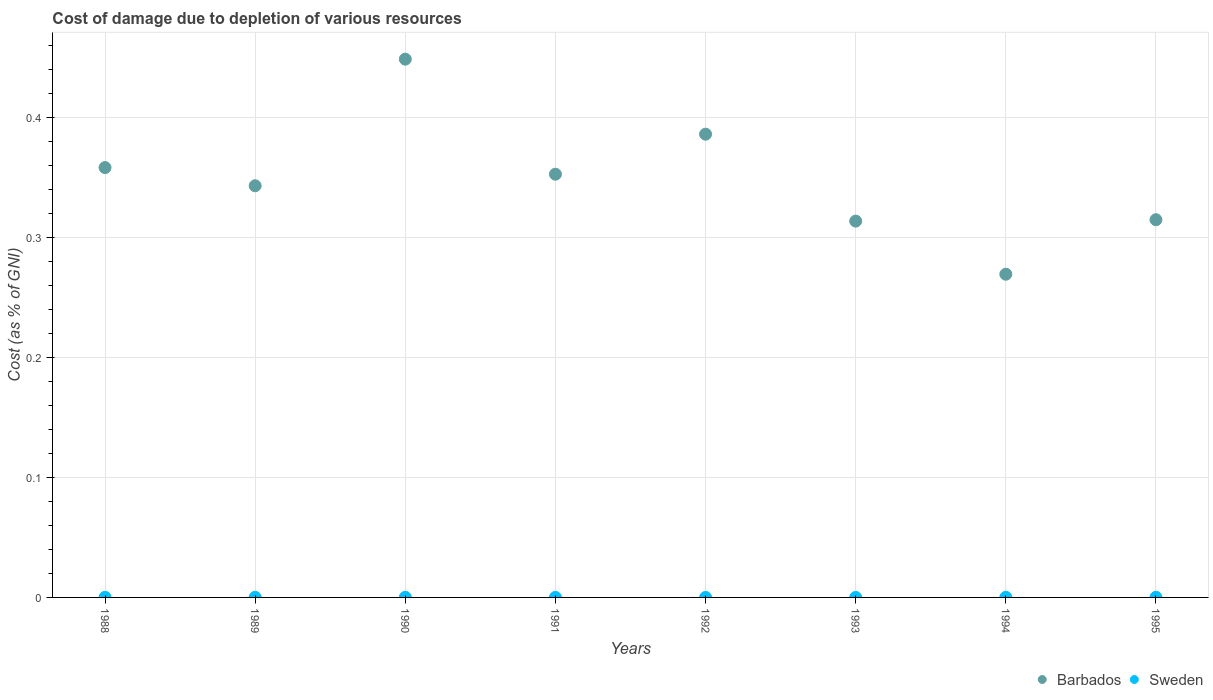How many different coloured dotlines are there?
Your response must be concise. 2. What is the cost of damage caused due to the depletion of various resources in Sweden in 1994?
Your answer should be compact. 0. Across all years, what is the maximum cost of damage caused due to the depletion of various resources in Sweden?
Your answer should be compact. 0. Across all years, what is the minimum cost of damage caused due to the depletion of various resources in Sweden?
Provide a short and direct response. 1.59427180676693e-5. What is the total cost of damage caused due to the depletion of various resources in Barbados in the graph?
Ensure brevity in your answer.  2.79. What is the difference between the cost of damage caused due to the depletion of various resources in Barbados in 1991 and that in 1995?
Provide a short and direct response. 0.04. What is the difference between the cost of damage caused due to the depletion of various resources in Sweden in 1989 and the cost of damage caused due to the depletion of various resources in Barbados in 1995?
Provide a succinct answer. -0.31. What is the average cost of damage caused due to the depletion of various resources in Sweden per year?
Your answer should be compact. 6.984566368503235e-5. In the year 1989, what is the difference between the cost of damage caused due to the depletion of various resources in Sweden and cost of damage caused due to the depletion of various resources in Barbados?
Your response must be concise. -0.34. In how many years, is the cost of damage caused due to the depletion of various resources in Sweden greater than 0.04 %?
Provide a succinct answer. 0. What is the ratio of the cost of damage caused due to the depletion of various resources in Barbados in 1993 to that in 1995?
Keep it short and to the point. 1. Is the cost of damage caused due to the depletion of various resources in Sweden in 1989 less than that in 1995?
Your answer should be very brief. Yes. Is the difference between the cost of damage caused due to the depletion of various resources in Sweden in 1989 and 1991 greater than the difference between the cost of damage caused due to the depletion of various resources in Barbados in 1989 and 1991?
Your answer should be very brief. Yes. What is the difference between the highest and the second highest cost of damage caused due to the depletion of various resources in Barbados?
Make the answer very short. 0.06. What is the difference between the highest and the lowest cost of damage caused due to the depletion of various resources in Sweden?
Provide a short and direct response. 9.43460556971317e-5. Is the sum of the cost of damage caused due to the depletion of various resources in Sweden in 1988 and 1992 greater than the maximum cost of damage caused due to the depletion of various resources in Barbados across all years?
Provide a succinct answer. No. Does the cost of damage caused due to the depletion of various resources in Sweden monotonically increase over the years?
Give a very brief answer. No. Is the cost of damage caused due to the depletion of various resources in Barbados strictly greater than the cost of damage caused due to the depletion of various resources in Sweden over the years?
Your answer should be compact. Yes. How many years are there in the graph?
Make the answer very short. 8. Are the values on the major ticks of Y-axis written in scientific E-notation?
Give a very brief answer. No. Does the graph contain grids?
Keep it short and to the point. Yes. Where does the legend appear in the graph?
Your answer should be compact. Bottom right. How are the legend labels stacked?
Give a very brief answer. Horizontal. What is the title of the graph?
Your answer should be very brief. Cost of damage due to depletion of various resources. Does "Hong Kong" appear as one of the legend labels in the graph?
Your response must be concise. No. What is the label or title of the Y-axis?
Give a very brief answer. Cost (as % of GNI). What is the Cost (as % of GNI) of Barbados in 1988?
Give a very brief answer. 0.36. What is the Cost (as % of GNI) in Sweden in 1988?
Offer a very short reply. 6.97562237093655e-5. What is the Cost (as % of GNI) of Barbados in 1989?
Provide a succinct answer. 0.34. What is the Cost (as % of GNI) in Sweden in 1989?
Make the answer very short. 8.442372501403629e-5. What is the Cost (as % of GNI) in Barbados in 1990?
Your answer should be compact. 0.45. What is the Cost (as % of GNI) in Sweden in 1990?
Your answer should be very brief. 9.81903606188115e-5. What is the Cost (as % of GNI) of Barbados in 1991?
Ensure brevity in your answer.  0.35. What is the Cost (as % of GNI) in Sweden in 1991?
Give a very brief answer. 5.16035580745399e-5. What is the Cost (as % of GNI) of Barbados in 1992?
Your answer should be compact. 0.39. What is the Cost (as % of GNI) of Sweden in 1992?
Your response must be concise. 2.46812414981984e-5. What is the Cost (as % of GNI) in Barbados in 1993?
Your response must be concise. 0.31. What is the Cost (as % of GNI) of Sweden in 1993?
Provide a succinct answer. 1.59427180676693e-5. What is the Cost (as % of GNI) of Barbados in 1994?
Offer a very short reply. 0.27. What is the Cost (as % of GNI) in Sweden in 1994?
Keep it short and to the point. 0. What is the Cost (as % of GNI) in Barbados in 1995?
Give a very brief answer. 0.32. What is the Cost (as % of GNI) in Sweden in 1995?
Keep it short and to the point. 0. Across all years, what is the maximum Cost (as % of GNI) of Barbados?
Your answer should be very brief. 0.45. Across all years, what is the maximum Cost (as % of GNI) of Sweden?
Ensure brevity in your answer.  0. Across all years, what is the minimum Cost (as % of GNI) of Barbados?
Keep it short and to the point. 0.27. Across all years, what is the minimum Cost (as % of GNI) in Sweden?
Provide a succinct answer. 1.59427180676693e-5. What is the total Cost (as % of GNI) of Barbados in the graph?
Your answer should be very brief. 2.79. What is the total Cost (as % of GNI) in Sweden in the graph?
Provide a short and direct response. 0. What is the difference between the Cost (as % of GNI) of Barbados in 1988 and that in 1989?
Offer a very short reply. 0.02. What is the difference between the Cost (as % of GNI) in Barbados in 1988 and that in 1990?
Ensure brevity in your answer.  -0.09. What is the difference between the Cost (as % of GNI) in Barbados in 1988 and that in 1991?
Offer a terse response. 0.01. What is the difference between the Cost (as % of GNI) of Barbados in 1988 and that in 1992?
Your answer should be compact. -0.03. What is the difference between the Cost (as % of GNI) in Barbados in 1988 and that in 1993?
Offer a very short reply. 0.04. What is the difference between the Cost (as % of GNI) in Barbados in 1988 and that in 1994?
Keep it short and to the point. 0.09. What is the difference between the Cost (as % of GNI) in Barbados in 1988 and that in 1995?
Your answer should be very brief. 0.04. What is the difference between the Cost (as % of GNI) of Sweden in 1988 and that in 1995?
Your response must be concise. -0. What is the difference between the Cost (as % of GNI) in Barbados in 1989 and that in 1990?
Offer a terse response. -0.11. What is the difference between the Cost (as % of GNI) of Barbados in 1989 and that in 1991?
Give a very brief answer. -0.01. What is the difference between the Cost (as % of GNI) of Sweden in 1989 and that in 1991?
Give a very brief answer. 0. What is the difference between the Cost (as % of GNI) in Barbados in 1989 and that in 1992?
Your response must be concise. -0.04. What is the difference between the Cost (as % of GNI) in Barbados in 1989 and that in 1993?
Offer a very short reply. 0.03. What is the difference between the Cost (as % of GNI) in Sweden in 1989 and that in 1993?
Offer a terse response. 0. What is the difference between the Cost (as % of GNI) of Barbados in 1989 and that in 1994?
Ensure brevity in your answer.  0.07. What is the difference between the Cost (as % of GNI) in Barbados in 1989 and that in 1995?
Make the answer very short. 0.03. What is the difference between the Cost (as % of GNI) in Barbados in 1990 and that in 1991?
Make the answer very short. 0.1. What is the difference between the Cost (as % of GNI) of Barbados in 1990 and that in 1992?
Provide a short and direct response. 0.06. What is the difference between the Cost (as % of GNI) in Sweden in 1990 and that in 1992?
Provide a short and direct response. 0. What is the difference between the Cost (as % of GNI) of Barbados in 1990 and that in 1993?
Your answer should be very brief. 0.14. What is the difference between the Cost (as % of GNI) in Barbados in 1990 and that in 1994?
Keep it short and to the point. 0.18. What is the difference between the Cost (as % of GNI) in Barbados in 1990 and that in 1995?
Provide a succinct answer. 0.13. What is the difference between the Cost (as % of GNI) in Barbados in 1991 and that in 1992?
Your answer should be very brief. -0.03. What is the difference between the Cost (as % of GNI) in Sweden in 1991 and that in 1992?
Provide a succinct answer. 0. What is the difference between the Cost (as % of GNI) in Barbados in 1991 and that in 1993?
Keep it short and to the point. 0.04. What is the difference between the Cost (as % of GNI) in Sweden in 1991 and that in 1993?
Keep it short and to the point. 0. What is the difference between the Cost (as % of GNI) in Barbados in 1991 and that in 1994?
Your response must be concise. 0.08. What is the difference between the Cost (as % of GNI) of Sweden in 1991 and that in 1994?
Offer a terse response. -0. What is the difference between the Cost (as % of GNI) in Barbados in 1991 and that in 1995?
Your response must be concise. 0.04. What is the difference between the Cost (as % of GNI) of Sweden in 1991 and that in 1995?
Your response must be concise. -0. What is the difference between the Cost (as % of GNI) of Barbados in 1992 and that in 1993?
Offer a very short reply. 0.07. What is the difference between the Cost (as % of GNI) of Barbados in 1992 and that in 1994?
Make the answer very short. 0.12. What is the difference between the Cost (as % of GNI) in Sweden in 1992 and that in 1994?
Provide a succinct answer. -0. What is the difference between the Cost (as % of GNI) in Barbados in 1992 and that in 1995?
Your answer should be very brief. 0.07. What is the difference between the Cost (as % of GNI) of Sweden in 1992 and that in 1995?
Provide a succinct answer. -0. What is the difference between the Cost (as % of GNI) of Barbados in 1993 and that in 1994?
Your answer should be very brief. 0.04. What is the difference between the Cost (as % of GNI) in Sweden in 1993 and that in 1994?
Ensure brevity in your answer.  -0. What is the difference between the Cost (as % of GNI) in Barbados in 1993 and that in 1995?
Your answer should be very brief. -0. What is the difference between the Cost (as % of GNI) in Sweden in 1993 and that in 1995?
Your answer should be compact. -0. What is the difference between the Cost (as % of GNI) in Barbados in 1994 and that in 1995?
Your response must be concise. -0.05. What is the difference between the Cost (as % of GNI) of Barbados in 1988 and the Cost (as % of GNI) of Sweden in 1989?
Provide a short and direct response. 0.36. What is the difference between the Cost (as % of GNI) of Barbados in 1988 and the Cost (as % of GNI) of Sweden in 1990?
Provide a succinct answer. 0.36. What is the difference between the Cost (as % of GNI) of Barbados in 1988 and the Cost (as % of GNI) of Sweden in 1991?
Your response must be concise. 0.36. What is the difference between the Cost (as % of GNI) of Barbados in 1988 and the Cost (as % of GNI) of Sweden in 1992?
Give a very brief answer. 0.36. What is the difference between the Cost (as % of GNI) of Barbados in 1988 and the Cost (as % of GNI) of Sweden in 1993?
Your answer should be compact. 0.36. What is the difference between the Cost (as % of GNI) of Barbados in 1988 and the Cost (as % of GNI) of Sweden in 1994?
Your response must be concise. 0.36. What is the difference between the Cost (as % of GNI) in Barbados in 1988 and the Cost (as % of GNI) in Sweden in 1995?
Your response must be concise. 0.36. What is the difference between the Cost (as % of GNI) in Barbados in 1989 and the Cost (as % of GNI) in Sweden in 1990?
Your answer should be very brief. 0.34. What is the difference between the Cost (as % of GNI) of Barbados in 1989 and the Cost (as % of GNI) of Sweden in 1991?
Your response must be concise. 0.34. What is the difference between the Cost (as % of GNI) of Barbados in 1989 and the Cost (as % of GNI) of Sweden in 1992?
Your response must be concise. 0.34. What is the difference between the Cost (as % of GNI) of Barbados in 1989 and the Cost (as % of GNI) of Sweden in 1993?
Offer a terse response. 0.34. What is the difference between the Cost (as % of GNI) of Barbados in 1989 and the Cost (as % of GNI) of Sweden in 1994?
Provide a succinct answer. 0.34. What is the difference between the Cost (as % of GNI) of Barbados in 1989 and the Cost (as % of GNI) of Sweden in 1995?
Give a very brief answer. 0.34. What is the difference between the Cost (as % of GNI) of Barbados in 1990 and the Cost (as % of GNI) of Sweden in 1991?
Offer a terse response. 0.45. What is the difference between the Cost (as % of GNI) in Barbados in 1990 and the Cost (as % of GNI) in Sweden in 1992?
Offer a very short reply. 0.45. What is the difference between the Cost (as % of GNI) in Barbados in 1990 and the Cost (as % of GNI) in Sweden in 1993?
Offer a very short reply. 0.45. What is the difference between the Cost (as % of GNI) of Barbados in 1990 and the Cost (as % of GNI) of Sweden in 1994?
Ensure brevity in your answer.  0.45. What is the difference between the Cost (as % of GNI) of Barbados in 1990 and the Cost (as % of GNI) of Sweden in 1995?
Offer a terse response. 0.45. What is the difference between the Cost (as % of GNI) in Barbados in 1991 and the Cost (as % of GNI) in Sweden in 1992?
Provide a short and direct response. 0.35. What is the difference between the Cost (as % of GNI) of Barbados in 1991 and the Cost (as % of GNI) of Sweden in 1993?
Ensure brevity in your answer.  0.35. What is the difference between the Cost (as % of GNI) in Barbados in 1991 and the Cost (as % of GNI) in Sweden in 1994?
Your response must be concise. 0.35. What is the difference between the Cost (as % of GNI) in Barbados in 1991 and the Cost (as % of GNI) in Sweden in 1995?
Provide a succinct answer. 0.35. What is the difference between the Cost (as % of GNI) of Barbados in 1992 and the Cost (as % of GNI) of Sweden in 1993?
Offer a terse response. 0.39. What is the difference between the Cost (as % of GNI) in Barbados in 1992 and the Cost (as % of GNI) in Sweden in 1994?
Your answer should be very brief. 0.39. What is the difference between the Cost (as % of GNI) of Barbados in 1992 and the Cost (as % of GNI) of Sweden in 1995?
Ensure brevity in your answer.  0.39. What is the difference between the Cost (as % of GNI) of Barbados in 1993 and the Cost (as % of GNI) of Sweden in 1994?
Provide a succinct answer. 0.31. What is the difference between the Cost (as % of GNI) of Barbados in 1993 and the Cost (as % of GNI) of Sweden in 1995?
Offer a terse response. 0.31. What is the difference between the Cost (as % of GNI) in Barbados in 1994 and the Cost (as % of GNI) in Sweden in 1995?
Provide a short and direct response. 0.27. What is the average Cost (as % of GNI) in Barbados per year?
Keep it short and to the point. 0.35. What is the average Cost (as % of GNI) of Sweden per year?
Provide a short and direct response. 0. In the year 1988, what is the difference between the Cost (as % of GNI) of Barbados and Cost (as % of GNI) of Sweden?
Make the answer very short. 0.36. In the year 1989, what is the difference between the Cost (as % of GNI) of Barbados and Cost (as % of GNI) of Sweden?
Offer a very short reply. 0.34. In the year 1990, what is the difference between the Cost (as % of GNI) of Barbados and Cost (as % of GNI) of Sweden?
Provide a short and direct response. 0.45. In the year 1991, what is the difference between the Cost (as % of GNI) in Barbados and Cost (as % of GNI) in Sweden?
Provide a succinct answer. 0.35. In the year 1992, what is the difference between the Cost (as % of GNI) of Barbados and Cost (as % of GNI) of Sweden?
Provide a short and direct response. 0.39. In the year 1993, what is the difference between the Cost (as % of GNI) in Barbados and Cost (as % of GNI) in Sweden?
Ensure brevity in your answer.  0.31. In the year 1994, what is the difference between the Cost (as % of GNI) of Barbados and Cost (as % of GNI) of Sweden?
Offer a terse response. 0.27. In the year 1995, what is the difference between the Cost (as % of GNI) of Barbados and Cost (as % of GNI) of Sweden?
Your answer should be compact. 0.32. What is the ratio of the Cost (as % of GNI) in Barbados in 1988 to that in 1989?
Your answer should be compact. 1.04. What is the ratio of the Cost (as % of GNI) in Sweden in 1988 to that in 1989?
Offer a very short reply. 0.83. What is the ratio of the Cost (as % of GNI) of Barbados in 1988 to that in 1990?
Keep it short and to the point. 0.8. What is the ratio of the Cost (as % of GNI) in Sweden in 1988 to that in 1990?
Your answer should be very brief. 0.71. What is the ratio of the Cost (as % of GNI) in Barbados in 1988 to that in 1991?
Your response must be concise. 1.02. What is the ratio of the Cost (as % of GNI) of Sweden in 1988 to that in 1991?
Ensure brevity in your answer.  1.35. What is the ratio of the Cost (as % of GNI) in Barbados in 1988 to that in 1992?
Your answer should be compact. 0.93. What is the ratio of the Cost (as % of GNI) in Sweden in 1988 to that in 1992?
Provide a succinct answer. 2.83. What is the ratio of the Cost (as % of GNI) of Barbados in 1988 to that in 1993?
Provide a succinct answer. 1.14. What is the ratio of the Cost (as % of GNI) in Sweden in 1988 to that in 1993?
Offer a very short reply. 4.38. What is the ratio of the Cost (as % of GNI) of Barbados in 1988 to that in 1994?
Your answer should be compact. 1.33. What is the ratio of the Cost (as % of GNI) of Sweden in 1988 to that in 1994?
Keep it short and to the point. 0.63. What is the ratio of the Cost (as % of GNI) in Barbados in 1988 to that in 1995?
Offer a very short reply. 1.14. What is the ratio of the Cost (as % of GNI) in Sweden in 1988 to that in 1995?
Ensure brevity in your answer.  0.67. What is the ratio of the Cost (as % of GNI) of Barbados in 1989 to that in 1990?
Your answer should be compact. 0.76. What is the ratio of the Cost (as % of GNI) of Sweden in 1989 to that in 1990?
Make the answer very short. 0.86. What is the ratio of the Cost (as % of GNI) of Barbados in 1989 to that in 1991?
Give a very brief answer. 0.97. What is the ratio of the Cost (as % of GNI) in Sweden in 1989 to that in 1991?
Give a very brief answer. 1.64. What is the ratio of the Cost (as % of GNI) of Barbados in 1989 to that in 1992?
Give a very brief answer. 0.89. What is the ratio of the Cost (as % of GNI) in Sweden in 1989 to that in 1992?
Provide a succinct answer. 3.42. What is the ratio of the Cost (as % of GNI) in Barbados in 1989 to that in 1993?
Your answer should be very brief. 1.09. What is the ratio of the Cost (as % of GNI) of Sweden in 1989 to that in 1993?
Make the answer very short. 5.3. What is the ratio of the Cost (as % of GNI) in Barbados in 1989 to that in 1994?
Your answer should be very brief. 1.27. What is the ratio of the Cost (as % of GNI) in Sweden in 1989 to that in 1994?
Provide a short and direct response. 0.77. What is the ratio of the Cost (as % of GNI) in Barbados in 1989 to that in 1995?
Provide a succinct answer. 1.09. What is the ratio of the Cost (as % of GNI) in Sweden in 1989 to that in 1995?
Ensure brevity in your answer.  0.81. What is the ratio of the Cost (as % of GNI) of Barbados in 1990 to that in 1991?
Give a very brief answer. 1.27. What is the ratio of the Cost (as % of GNI) in Sweden in 1990 to that in 1991?
Make the answer very short. 1.9. What is the ratio of the Cost (as % of GNI) in Barbados in 1990 to that in 1992?
Your answer should be very brief. 1.16. What is the ratio of the Cost (as % of GNI) of Sweden in 1990 to that in 1992?
Give a very brief answer. 3.98. What is the ratio of the Cost (as % of GNI) in Barbados in 1990 to that in 1993?
Offer a very short reply. 1.43. What is the ratio of the Cost (as % of GNI) of Sweden in 1990 to that in 1993?
Offer a very short reply. 6.16. What is the ratio of the Cost (as % of GNI) of Barbados in 1990 to that in 1994?
Offer a terse response. 1.67. What is the ratio of the Cost (as % of GNI) in Sweden in 1990 to that in 1994?
Your answer should be compact. 0.89. What is the ratio of the Cost (as % of GNI) of Barbados in 1990 to that in 1995?
Make the answer very short. 1.43. What is the ratio of the Cost (as % of GNI) of Sweden in 1990 to that in 1995?
Offer a very short reply. 0.95. What is the ratio of the Cost (as % of GNI) of Barbados in 1991 to that in 1992?
Your answer should be compact. 0.91. What is the ratio of the Cost (as % of GNI) of Sweden in 1991 to that in 1992?
Offer a terse response. 2.09. What is the ratio of the Cost (as % of GNI) in Barbados in 1991 to that in 1993?
Ensure brevity in your answer.  1.12. What is the ratio of the Cost (as % of GNI) in Sweden in 1991 to that in 1993?
Offer a very short reply. 3.24. What is the ratio of the Cost (as % of GNI) in Barbados in 1991 to that in 1994?
Provide a short and direct response. 1.31. What is the ratio of the Cost (as % of GNI) of Sweden in 1991 to that in 1994?
Your response must be concise. 0.47. What is the ratio of the Cost (as % of GNI) in Barbados in 1991 to that in 1995?
Your answer should be compact. 1.12. What is the ratio of the Cost (as % of GNI) in Sweden in 1991 to that in 1995?
Provide a succinct answer. 0.5. What is the ratio of the Cost (as % of GNI) in Barbados in 1992 to that in 1993?
Give a very brief answer. 1.23. What is the ratio of the Cost (as % of GNI) in Sweden in 1992 to that in 1993?
Make the answer very short. 1.55. What is the ratio of the Cost (as % of GNI) in Barbados in 1992 to that in 1994?
Ensure brevity in your answer.  1.43. What is the ratio of the Cost (as % of GNI) of Sweden in 1992 to that in 1994?
Your answer should be very brief. 0.22. What is the ratio of the Cost (as % of GNI) in Barbados in 1992 to that in 1995?
Offer a very short reply. 1.23. What is the ratio of the Cost (as % of GNI) of Sweden in 1992 to that in 1995?
Give a very brief answer. 0.24. What is the ratio of the Cost (as % of GNI) of Barbados in 1993 to that in 1994?
Make the answer very short. 1.16. What is the ratio of the Cost (as % of GNI) in Sweden in 1993 to that in 1994?
Provide a succinct answer. 0.14. What is the ratio of the Cost (as % of GNI) in Barbados in 1993 to that in 1995?
Offer a terse response. 1. What is the ratio of the Cost (as % of GNI) of Sweden in 1993 to that in 1995?
Keep it short and to the point. 0.15. What is the ratio of the Cost (as % of GNI) in Barbados in 1994 to that in 1995?
Give a very brief answer. 0.86. What is the ratio of the Cost (as % of GNI) in Sweden in 1994 to that in 1995?
Provide a succinct answer. 1.06. What is the difference between the highest and the second highest Cost (as % of GNI) in Barbados?
Keep it short and to the point. 0.06. What is the difference between the highest and the lowest Cost (as % of GNI) of Barbados?
Keep it short and to the point. 0.18. 